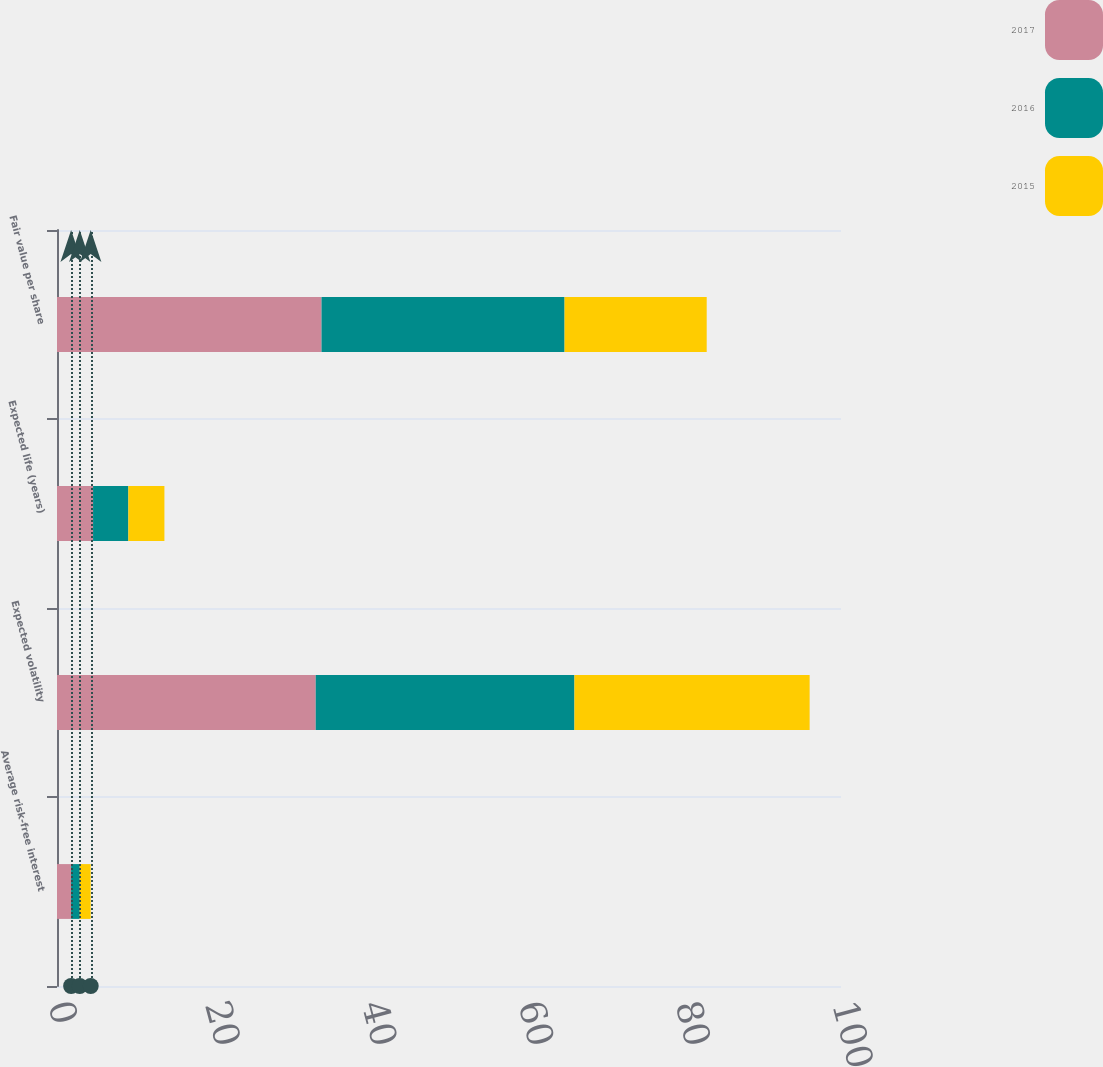<chart> <loc_0><loc_0><loc_500><loc_500><stacked_bar_chart><ecel><fcel>Average risk-free interest<fcel>Expected volatility<fcel>Expected life (years)<fcel>Fair value per share<nl><fcel>2017<fcel>1.8<fcel>33<fcel>4.6<fcel>33.74<nl><fcel>2016<fcel>1.1<fcel>33<fcel>4.5<fcel>31<nl><fcel>2015<fcel>1.4<fcel>30<fcel>4.6<fcel>18.13<nl></chart> 